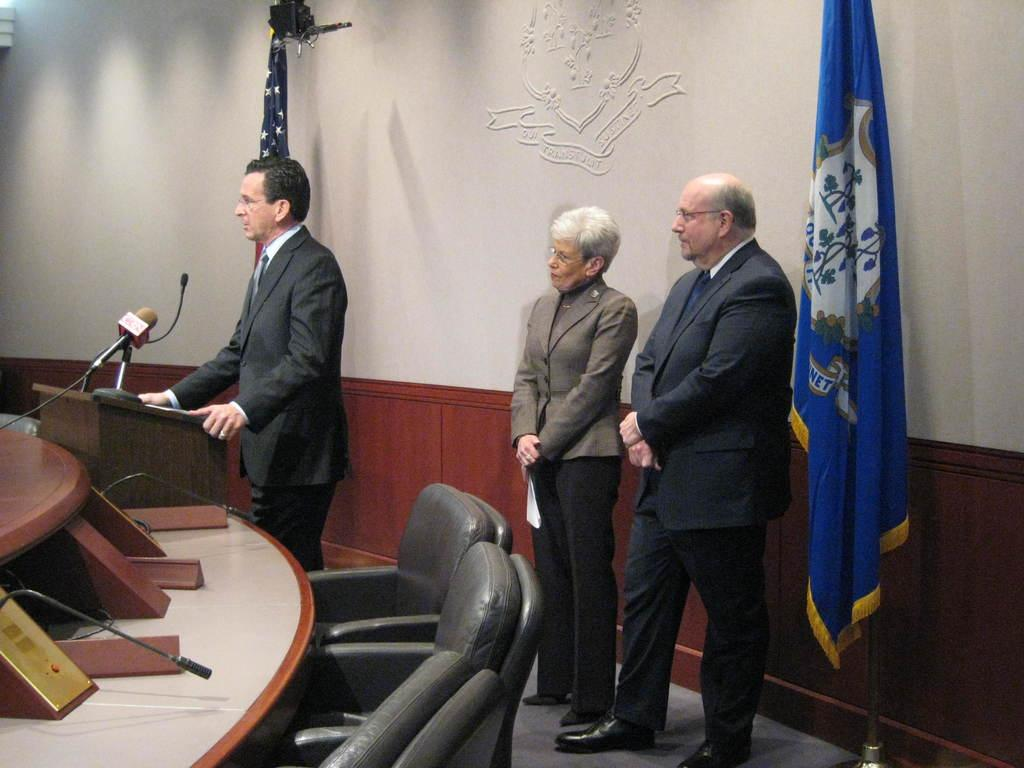What is the man in the grey suit wearing in the image? The man is wearing a grey suit in the image. What is the position of the man in the grey suit? The man is standing in the image. Can you describe the other people in the image? There is a woman and another man in the image, and both are standing. What object related to a country or organization can be seen in the image? There is a flag in the image. What piece of furniture is present in the image? There is a chair in the image. What device is used for amplifying sound in the image? There is a mic in the image. What type of hook is the man in the grey suit holding in the image? There is no hook present in the image. 